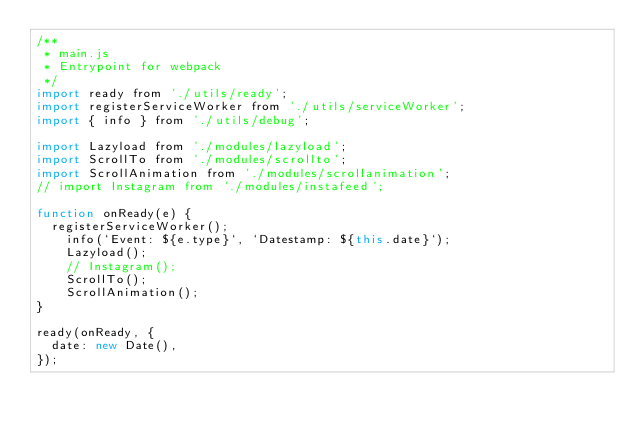Convert code to text. <code><loc_0><loc_0><loc_500><loc_500><_JavaScript_>/**
 * main.js
 * Entrypoint for webpack
 */
import ready from './utils/ready';
import registerServiceWorker from './utils/serviceWorker';
import { info } from './utils/debug';

import Lazyload from './modules/lazyload';
import ScrollTo from './modules/scrollto';
import ScrollAnimation from './modules/scrollanimation';
// import Instagram from './modules/instafeed';

function onReady(e) {
  registerServiceWorker();
	info(`Event: ${e.type}`, `Datestamp: ${this.date}`);
	Lazyload();
	// Instagram();
	ScrollTo();
	ScrollAnimation();
}

ready(onReady, {
  date: new Date(),
});
</code> 